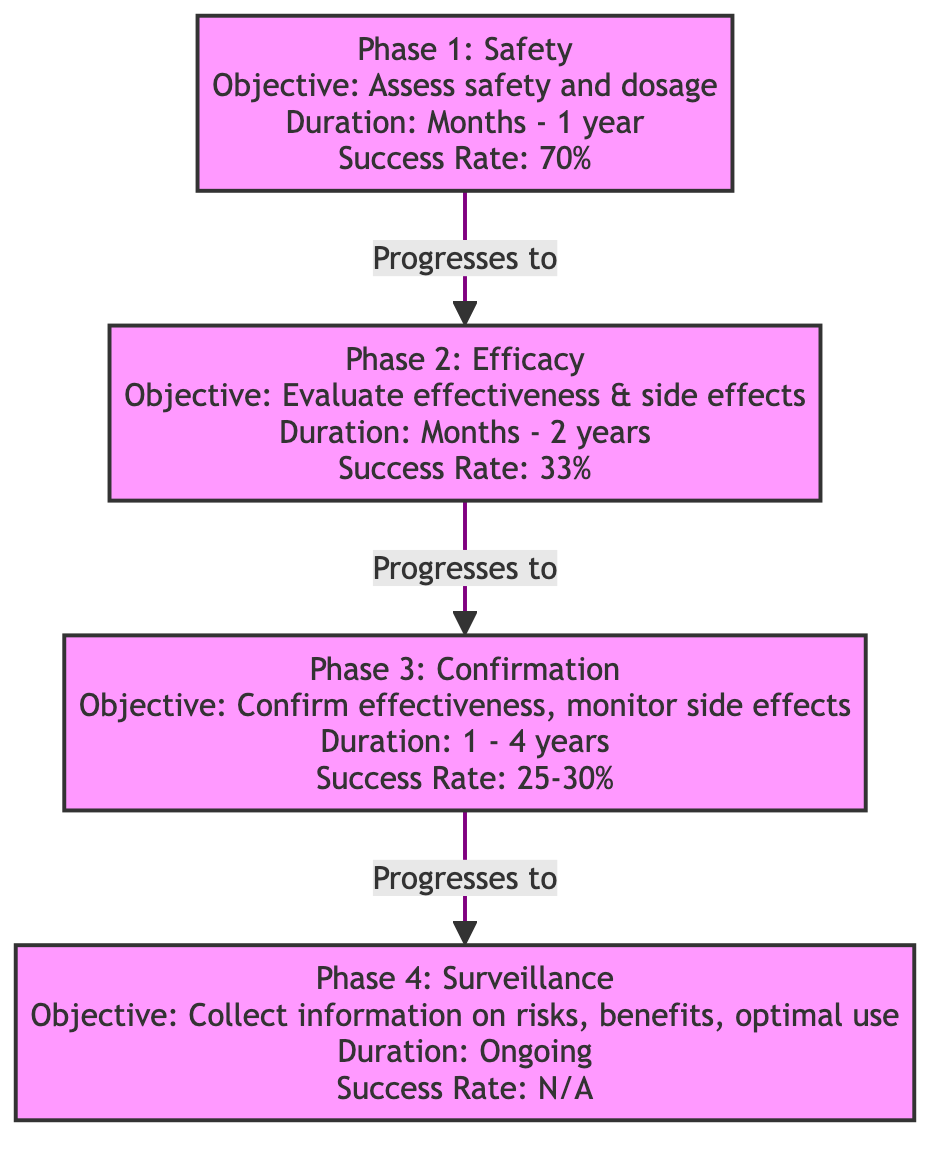What is the main objective of Phase 2? The diagram states that the objective of Phase 2 is to "Evaluate effectiveness & side effects." I directly reference the information given within the phase labeled for Phase 2.
Answer: Evaluate effectiveness & side effects How long does Phase 1 last? According to the diagram, Phase 1 lasts "Months - 1 year." This information is explicitly mentioned in the duration section of Phase 1.
Answer: Months - 1 year What is the success rate of Phase 3? The diagram indicates that the success rate of Phase 3 is "25-30%." This is found under the success rate section corresponding to Phase 3.
Answer: 25-30% Which phase follows Phase 2? The flowchart depicts that Phase 2 directly progresses to Phase 3, meaning Phase 3 follows Phase 2. This is demonstrated by the arrow linking these two phases in the diagram.
Answer: Phase 3 What is the objective of Phase 4? The diagram states that the objective of Phase 4 is to "Collect information on risks, benefits, optimal use." This information is presented in the details of Phase 4.
Answer: Collect information on risks, benefits, optimal use What is the duration of Phase 3? The diagram specifies that Phase 3 has a duration of "1 - 4 years." This information is clearly provided within the duration section of Phase 3.
Answer: 1 - 4 years Which phase has the highest success rate? By comparing the success rates of all phases listed, Phase 1 has the highest success rate at "70%," making it the phase with the highest success rate.
Answer: Phase 1 Is the success rate of Phase 4 mentioned in the diagram? The diagram notes that the success rate for Phase 4 is "N/A," indicating that it is not applicable or not provided. This detail is explicitly stated in the success rate section of Phase 4.
Answer: N/A How many phases are depicted in the diagram? The rendered diagram contains four phases: Phase 1, Phase 2, Phase 3, and Phase 4. By counting the distinct phase nodes, we arrive at the total number.
Answer: 4 What is the main objective of Phase 1? The diagram outlines that the objective of Phase 1 is to "Assess safety and dosage." This information is directly stated in the phase details for Phase 1.
Answer: Assess safety and dosage 